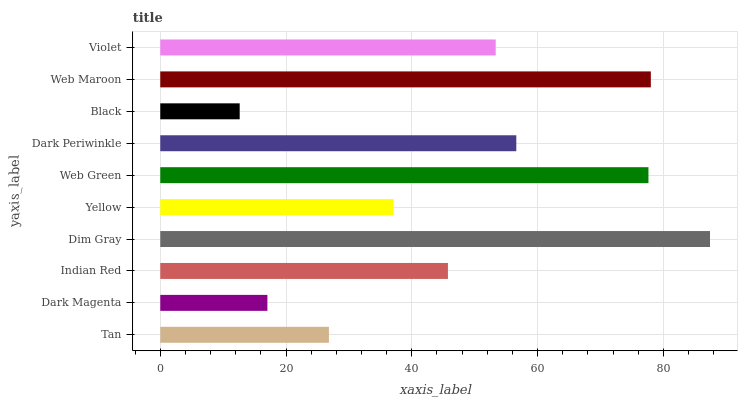Is Black the minimum?
Answer yes or no. Yes. Is Dim Gray the maximum?
Answer yes or no. Yes. Is Dark Magenta the minimum?
Answer yes or no. No. Is Dark Magenta the maximum?
Answer yes or no. No. Is Tan greater than Dark Magenta?
Answer yes or no. Yes. Is Dark Magenta less than Tan?
Answer yes or no. Yes. Is Dark Magenta greater than Tan?
Answer yes or no. No. Is Tan less than Dark Magenta?
Answer yes or no. No. Is Violet the high median?
Answer yes or no. Yes. Is Indian Red the low median?
Answer yes or no. Yes. Is Web Green the high median?
Answer yes or no. No. Is Dark Periwinkle the low median?
Answer yes or no. No. 